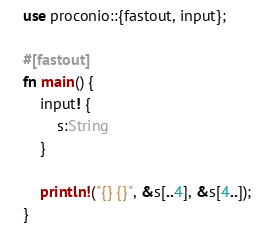<code> <loc_0><loc_0><loc_500><loc_500><_Rust_>use proconio::{fastout, input};

#[fastout]
fn main() {
    input! {
        s:String
    }

    println!("{} {}", &s[..4], &s[4..]);
}
</code> 